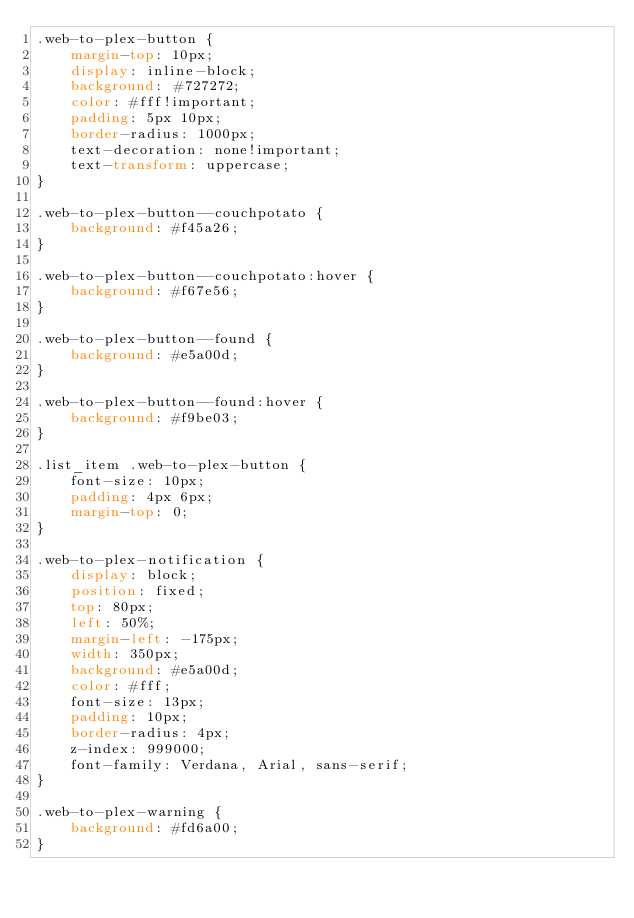<code> <loc_0><loc_0><loc_500><loc_500><_CSS_>.web-to-plex-button {
	margin-top: 10px;
	display: inline-block;
	background: #727272;
	color: #fff!important;
	padding: 5px 10px;
	border-radius: 1000px;
	text-decoration: none!important;
	text-transform: uppercase;
}

.web-to-plex-button--couchpotato {
	background: #f45a26;
}

.web-to-plex-button--couchpotato:hover {
	background: #f67e56;
}

.web-to-plex-button--found {
	background: #e5a00d;
}

.web-to-plex-button--found:hover {
	background: #f9be03;
}

.list_item .web-to-plex-button {
	font-size: 10px;
	padding: 4px 6px;
	margin-top: 0;
}

.web-to-plex-notification {
	display: block;
	position: fixed;
	top: 80px;
	left: 50%;
	margin-left: -175px;
	width: 350px;
	background: #e5a00d;
	color: #fff;
	font-size: 13px;
	padding: 10px;
	border-radius: 4px;
	z-index: 999000;
	font-family: Verdana, Arial, sans-serif;
}

.web-to-plex-warning {
	background: #fd6a00;
}
</code> 